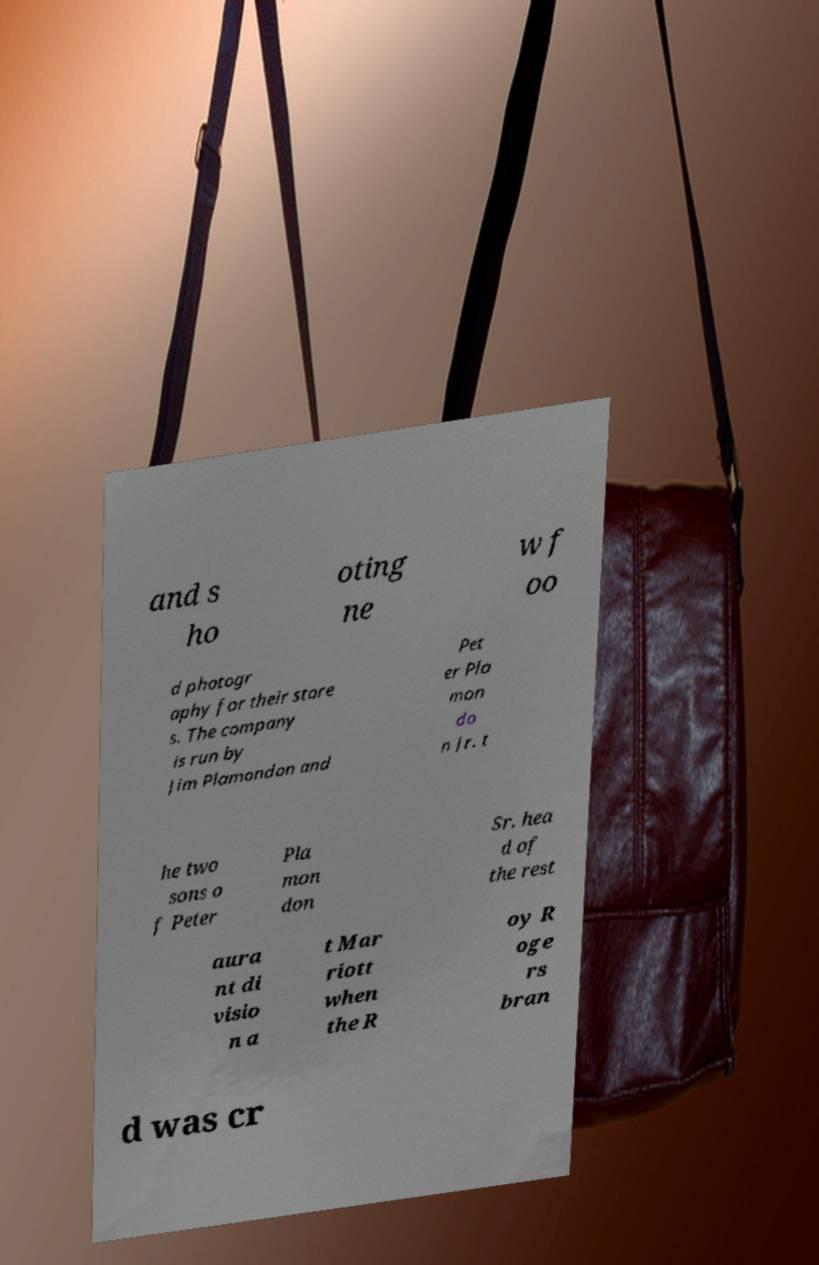Could you extract and type out the text from this image? and s ho oting ne w f oo d photogr aphy for their store s. The company is run by Jim Plamondon and Pet er Pla mon do n Jr. t he two sons o f Peter Pla mon don Sr. hea d of the rest aura nt di visio n a t Mar riott when the R oy R oge rs bran d was cr 